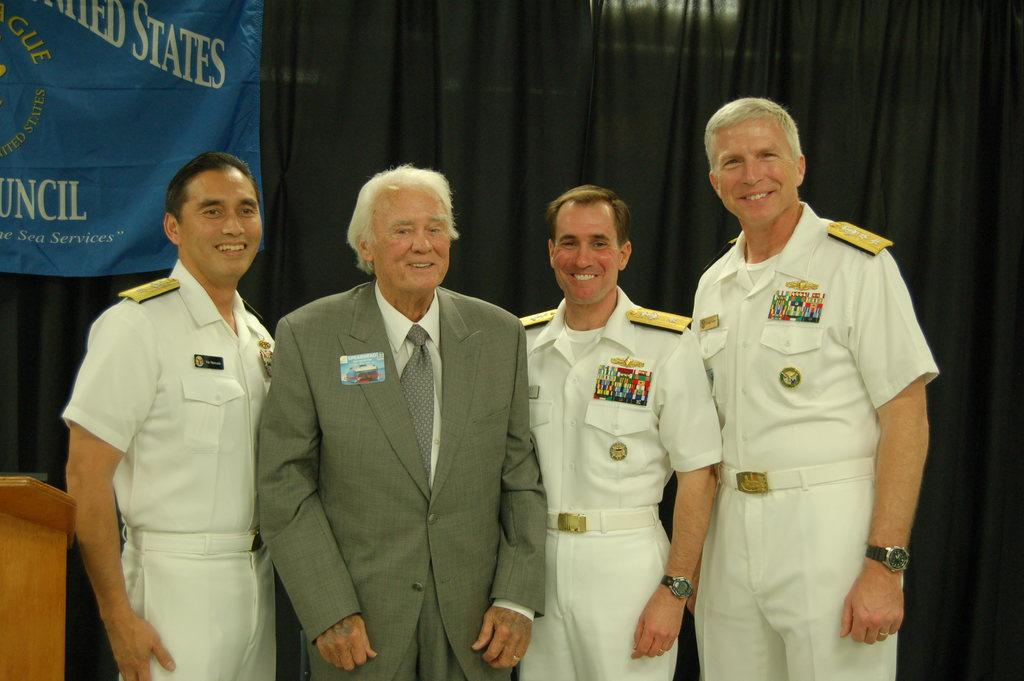<image>
Render a clear and concise summary of the photo. Military men standing for a photograph with a blue banner in the background that says United States. 